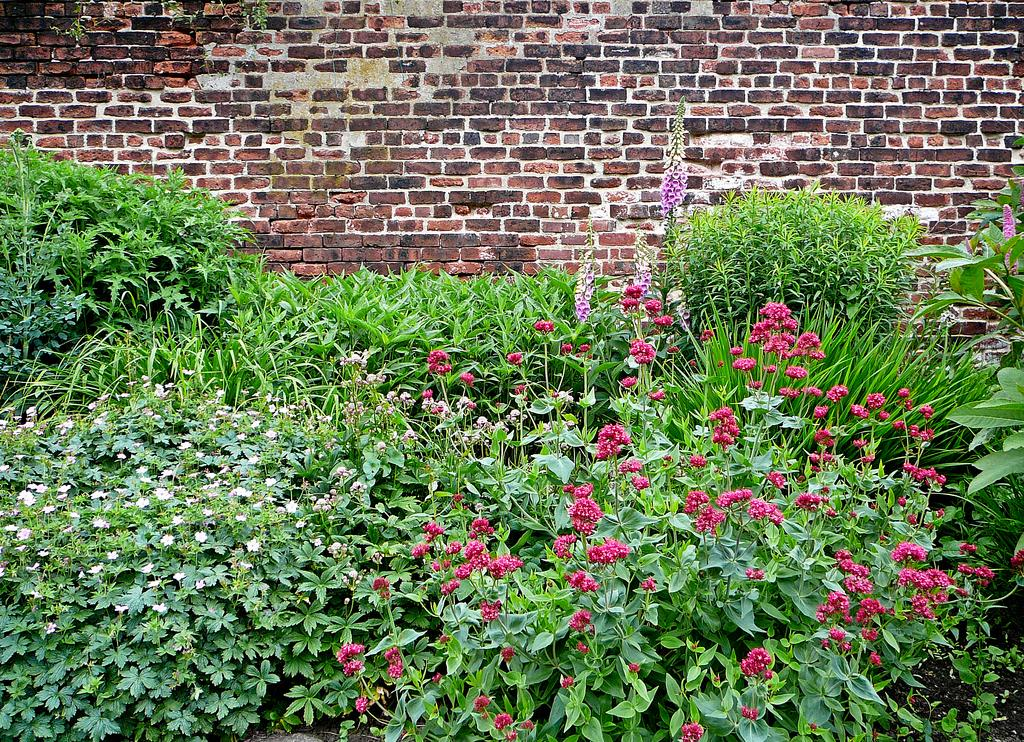What types of living organisms are present in the image? The image contains many plants. What specific features can be observed on the plants? The plants have flowers. What type of material is used to construct the wall in the background of the image? The wall in the background of the image is made of bricks. What color is the pin on the shirt in the image? There is no pin or shirt present in the image; it only contains plants and a brick wall. 